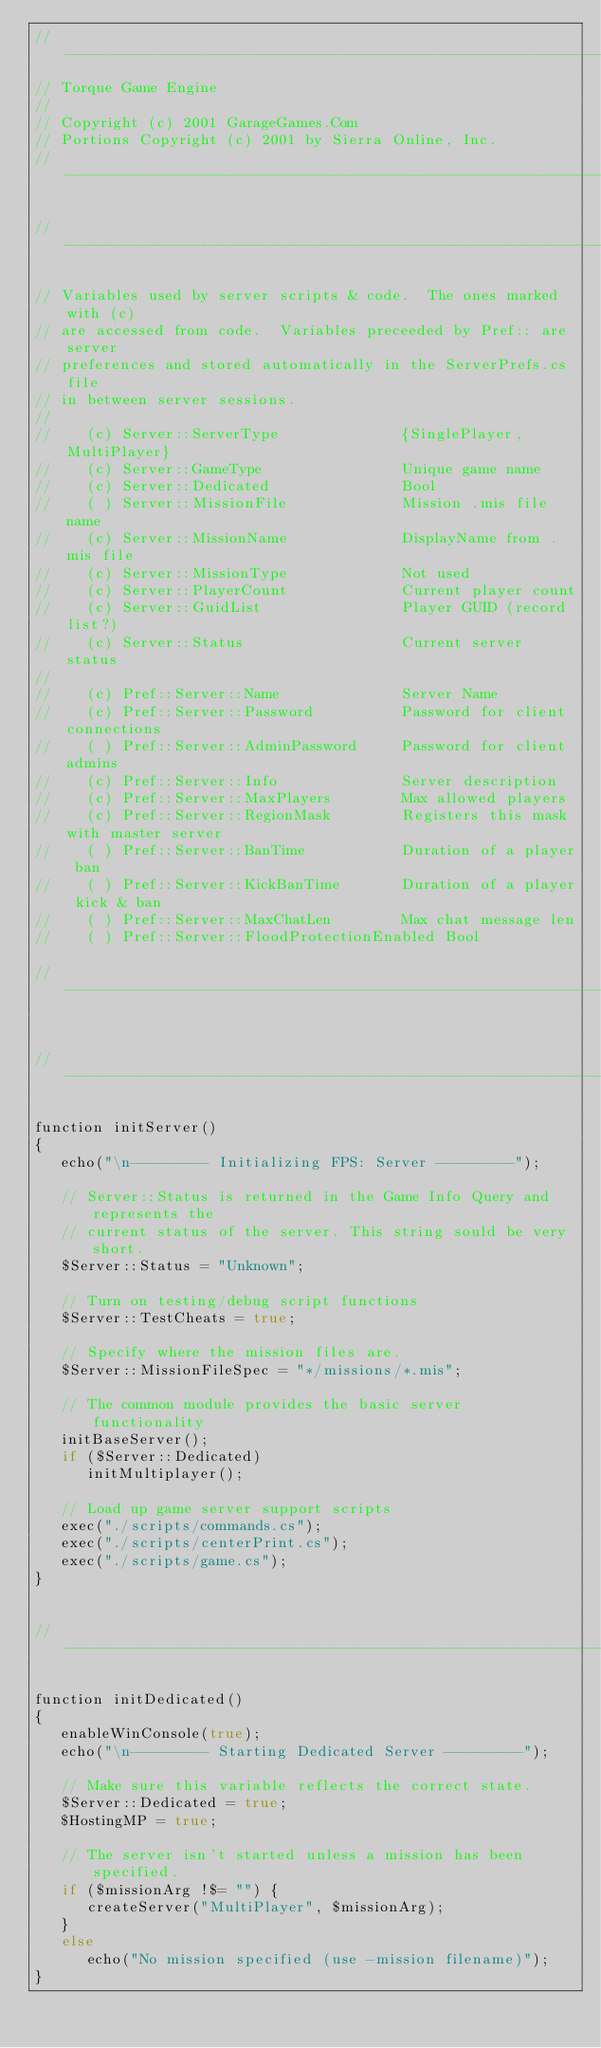Convert code to text. <code><loc_0><loc_0><loc_500><loc_500><_C#_>//-----------------------------------------------------------------------------
// Torque Game Engine
//
// Copyright (c) 2001 GarageGames.Com
// Portions Copyright (c) 2001 by Sierra Online, Inc.
//-----------------------------------------------------------------------------

//-----------------------------------------------------------------------------

// Variables used by server scripts & code.  The ones marked with (c)
// are accessed from code.  Variables preceeded by Pref:: are server
// preferences and stored automatically in the ServerPrefs.cs file
// in between server sessions.
//
//    (c) Server::ServerType              {SinglePlayer, MultiPlayer}
//    (c) Server::GameType                Unique game name
//    (c) Server::Dedicated               Bool
//    ( ) Server::MissionFile             Mission .mis file name
//    (c) Server::MissionName             DisplayName from .mis file
//    (c) Server::MissionType             Not used
//    (c) Server::PlayerCount             Current player count
//    (c) Server::GuidList                Player GUID (record list?)
//    (c) Server::Status                  Current server status
//
//    (c) Pref::Server::Name              Server Name
//    (c) Pref::Server::Password          Password for client connections
//    ( ) Pref::Server::AdminPassword     Password for client admins
//    (c) Pref::Server::Info              Server description
//    (c) Pref::Server::MaxPlayers        Max allowed players
//    (c) Pref::Server::RegionMask        Registers this mask with master server
//    ( ) Pref::Server::BanTime           Duration of a player ban
//    ( ) Pref::Server::KickBanTime       Duration of a player kick & ban
//    ( ) Pref::Server::MaxChatLen        Max chat message len
//    ( ) Pref::Server::FloodProtectionEnabled Bool

//-----------------------------------------------------------------------------


//-----------------------------------------------------------------------------

function initServer()
{
   echo("\n--------- Initializing FPS: Server ---------");

   // Server::Status is returned in the Game Info Query and represents the
   // current status of the server. This string sould be very short.
   $Server::Status = "Unknown";

   // Turn on testing/debug script functions
   $Server::TestCheats = true;

   // Specify where the mission files are.
   $Server::MissionFileSpec = "*/missions/*.mis";

   // The common module provides the basic server functionality
   initBaseServer();
   if ($Server::Dedicated)
      initMultiplayer();

   // Load up game server support scripts
   exec("./scripts/commands.cs");
   exec("./scripts/centerPrint.cs");
   exec("./scripts/game.cs");
}


//-----------------------------------------------------------------------------

function initDedicated()
{
   enableWinConsole(true);
   echo("\n--------- Starting Dedicated Server ---------");

   // Make sure this variable reflects the correct state.
   $Server::Dedicated = true;
   $HostingMP = true;

   // The server isn't started unless a mission has been specified.
   if ($missionArg !$= "") {
      createServer("MultiPlayer", $missionArg);
   }
   else
      echo("No mission specified (use -mission filename)");
}

</code> 